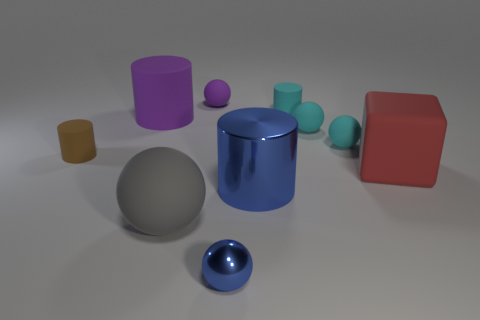Subtract all gray rubber spheres. How many spheres are left? 4 Subtract all blue cylinders. How many cylinders are left? 3 Subtract 2 spheres. How many spheres are left? 3 Subtract all cylinders. How many objects are left? 6 Subtract all red cylinders. Subtract all red cubes. How many cylinders are left? 4 Subtract all blue cubes. How many green balls are left? 0 Subtract 1 brown cylinders. How many objects are left? 9 Subtract all small cyan balls. Subtract all small blue shiny spheres. How many objects are left? 7 Add 5 purple rubber things. How many purple rubber things are left? 7 Add 1 cyan cylinders. How many cyan cylinders exist? 2 